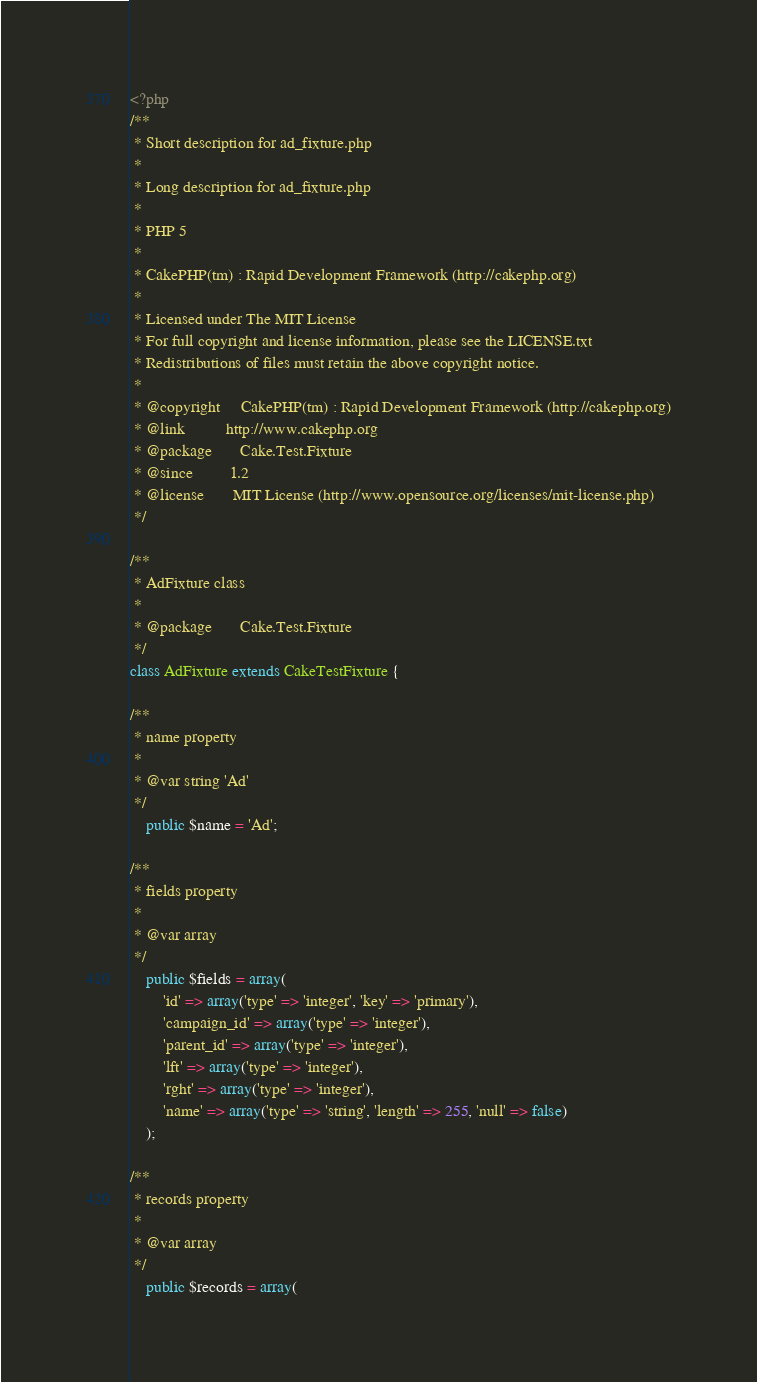Convert code to text. <code><loc_0><loc_0><loc_500><loc_500><_PHP_><?php
/**
 * Short description for ad_fixture.php
 *
 * Long description for ad_fixture.php
 *
 * PHP 5
 *
 * CakePHP(tm) : Rapid Development Framework (http://cakephp.org)
 *
 * Licensed under The MIT License
 * For full copyright and license information, please see the LICENSE.txt
 * Redistributions of files must retain the above copyright notice.
 *
 * @copyright     CakePHP(tm) : Rapid Development Framework (http://cakephp.org)
 * @link          http://www.cakephp.org
 * @package       Cake.Test.Fixture
 * @since         1.2
 * @license       MIT License (http://www.opensource.org/licenses/mit-license.php)
 */

/**
 * AdFixture class
 *
 * @package       Cake.Test.Fixture
 */
class AdFixture extends CakeTestFixture {

/**
 * name property
 *
 * @var string 'Ad'
 */
	public $name = 'Ad';

/**
 * fields property
 *
 * @var array
 */
	public $fields = array(
		'id' => array('type' => 'integer', 'key' => 'primary'),
		'campaign_id' => array('type' => 'integer'),
		'parent_id' => array('type' => 'integer'),
		'lft' => array('type' => 'integer'),
		'rght' => array('type' => 'integer'),
		'name' => array('type' => 'string', 'length' => 255, 'null' => false)
	);

/**
 * records property
 *
 * @var array
 */
	public $records = array(</code> 